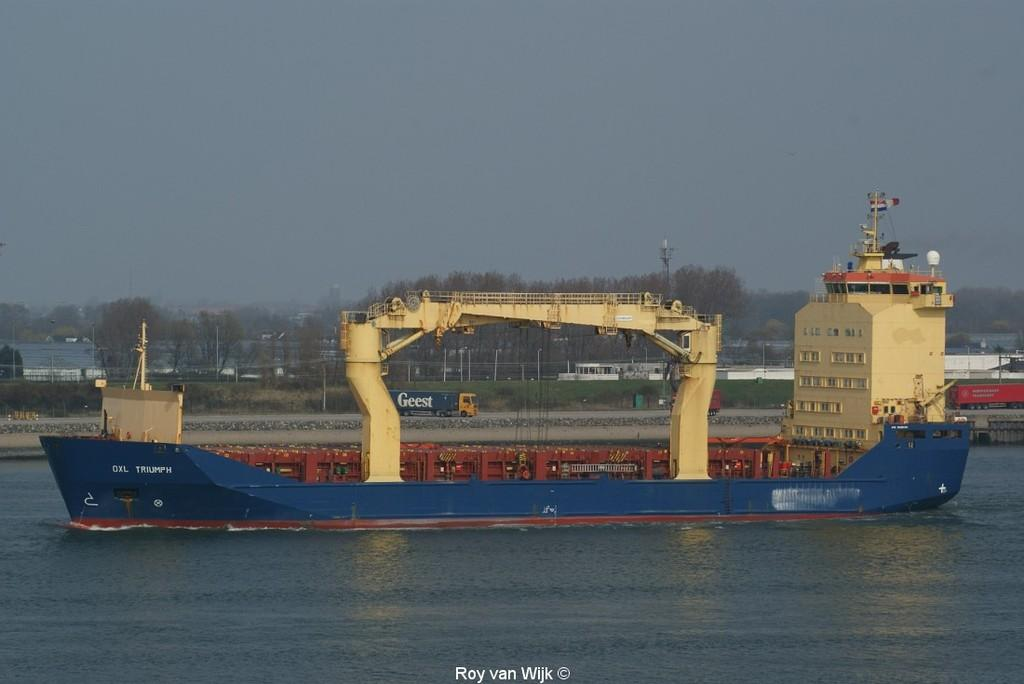What type of vehicle can be seen in the image? There are trucks in the image. What structure is present in the image? There is a building and a tower in the image. What type of transportation is visible in the image? There is a boat in the image. What architectural feature is present in the image? There is a bridge in the image. What type of natural element is visible in the image? There are trees in the image. What is visible at the bottom of the image? There is water visible at the bottom of the image. What is visible at the top of the image? There is a sky visible at the top of the image. Can you hear the song being sung by the fairies in the image? There are no fairies or songs present in the image. How many frogs are sitting on the boat in the image? There are no frogs present in the image. 